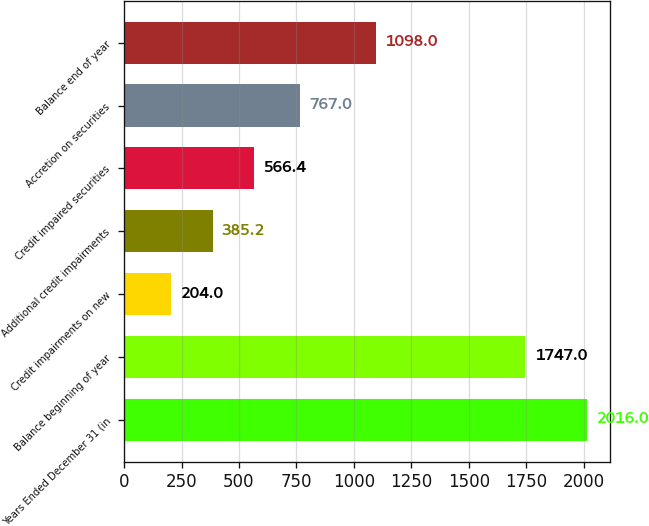Convert chart to OTSL. <chart><loc_0><loc_0><loc_500><loc_500><bar_chart><fcel>Years Ended December 31 (in<fcel>Balance beginning of year<fcel>Credit impairments on new<fcel>Additional credit impairments<fcel>Credit impaired securities<fcel>Accretion on securities<fcel>Balance end of year<nl><fcel>2016<fcel>1747<fcel>204<fcel>385.2<fcel>566.4<fcel>767<fcel>1098<nl></chart> 